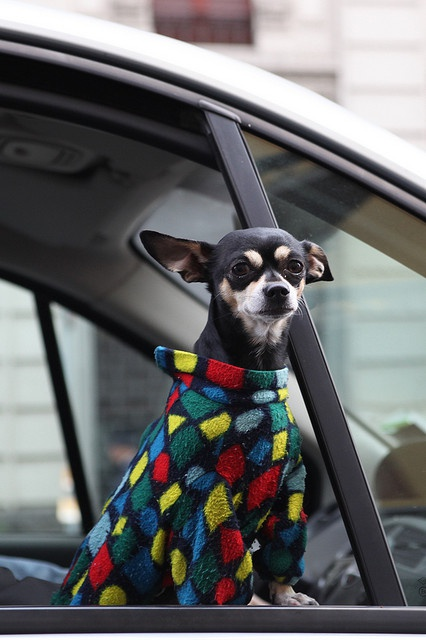Describe the objects in this image and their specific colors. I can see car in white, black, gray, lightgray, and darkgray tones and dog in white, black, gray, teal, and navy tones in this image. 